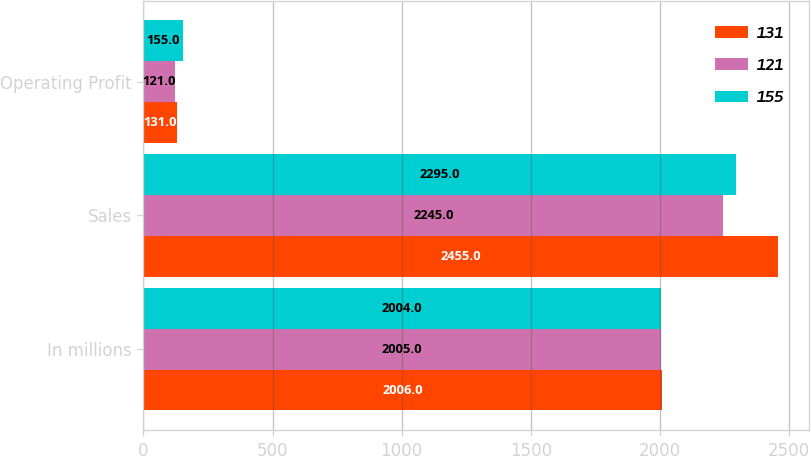Convert chart. <chart><loc_0><loc_0><loc_500><loc_500><stacked_bar_chart><ecel><fcel>In millions<fcel>Sales<fcel>Operating Profit<nl><fcel>131<fcel>2006<fcel>2455<fcel>131<nl><fcel>121<fcel>2005<fcel>2245<fcel>121<nl><fcel>155<fcel>2004<fcel>2295<fcel>155<nl></chart> 